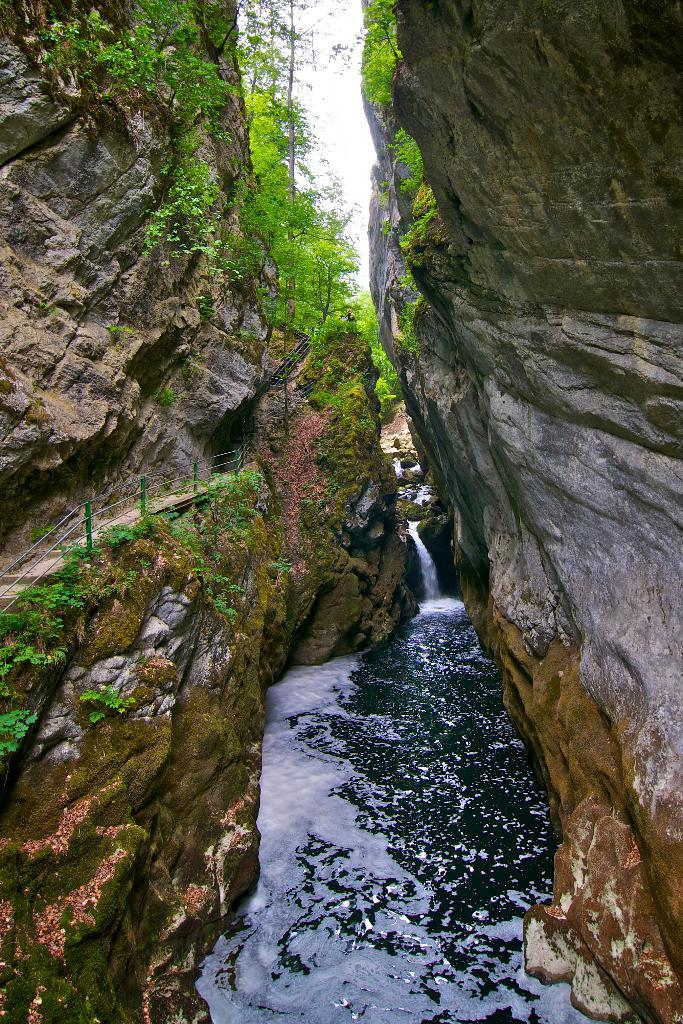What is the main feature of the image? The main feature of the image is a river flowing between two cliffs. What can be seen on the cliffs? There is a railing on one cliff and a path on another cliff. What is visible in the background of the image? There are trees and the sky visible in the background of the image. What type of shock can be seen in the image? There is no shock present in the image; it features a river flowing between two cliffs, with a railing and a path on the cliffs, and trees and the sky in the background. 